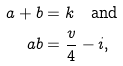<formula> <loc_0><loc_0><loc_500><loc_500>a + b & = k \quad \text {and} \\ a b & = \frac { v } { 4 } - i ,</formula> 